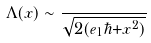Convert formula to latex. <formula><loc_0><loc_0><loc_500><loc_500>\Lambda ( x ) \sim \frac { } { \sqrt { 2 ( e _ { 1 } \hbar { + } x ^ { 2 } ) } }</formula> 